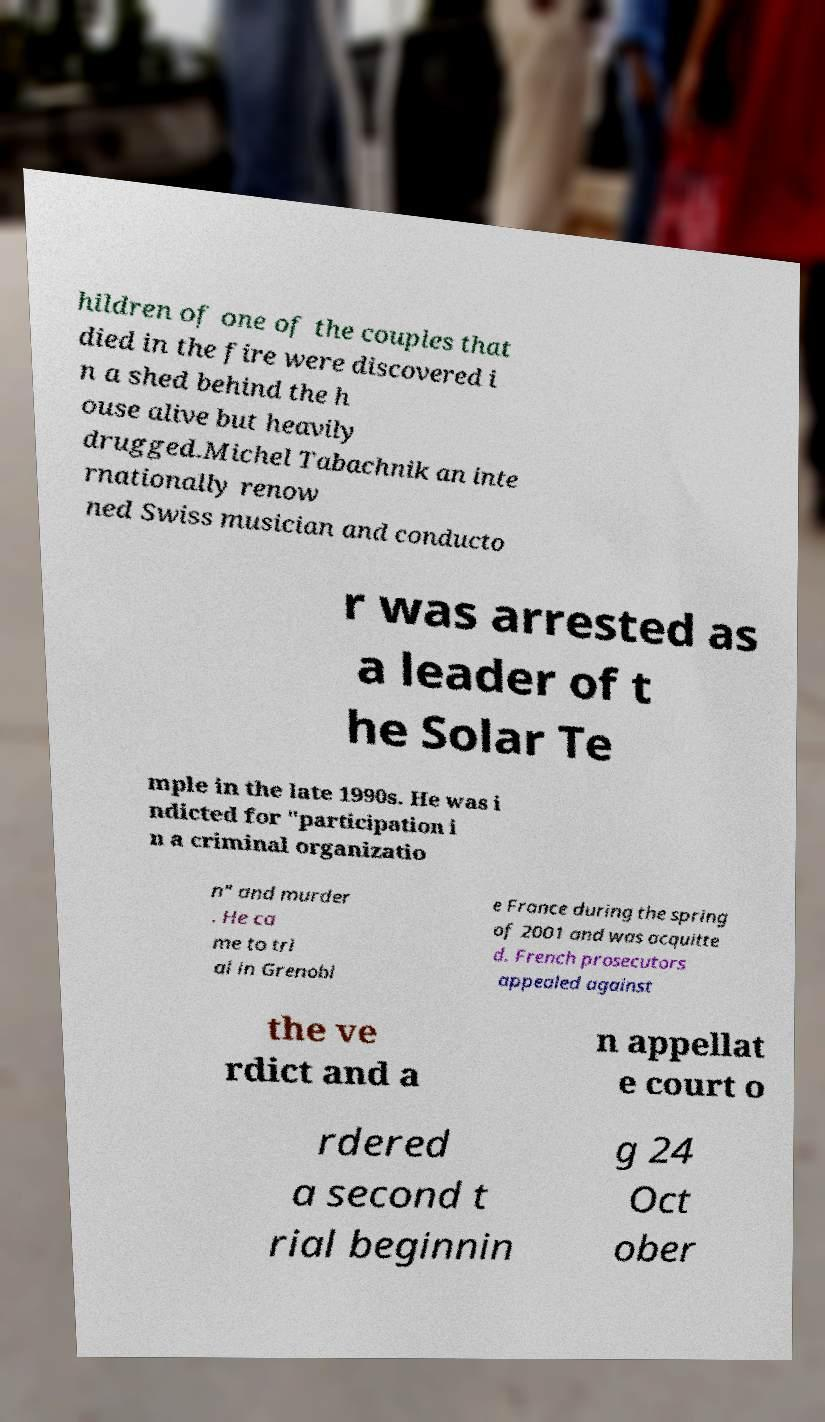There's text embedded in this image that I need extracted. Can you transcribe it verbatim? hildren of one of the couples that died in the fire were discovered i n a shed behind the h ouse alive but heavily drugged.Michel Tabachnik an inte rnationally renow ned Swiss musician and conducto r was arrested as a leader of t he Solar Te mple in the late 1990s. He was i ndicted for "participation i n a criminal organizatio n" and murder . He ca me to tri al in Grenobl e France during the spring of 2001 and was acquitte d. French prosecutors appealed against the ve rdict and a n appellat e court o rdered a second t rial beginnin g 24 Oct ober 